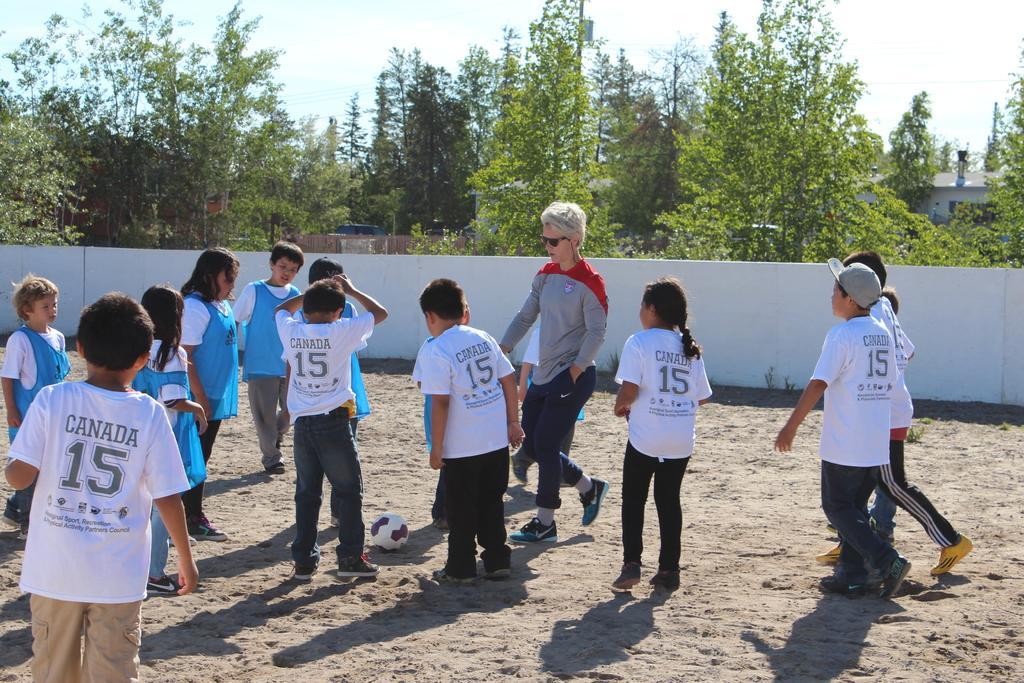Can you describe this image briefly? In this image in the middle, there is a man, he wears a t shirt, trouser and shoes. On the right there is a boy, he wears a t shirt, trouser and shoes and there is a girl, she wears a t shirt, trouser and shoes and there are some children. On the left there are many children. At the bottom there is a ball and land. In the background there are trees, wall, houses, sky and clouds. 